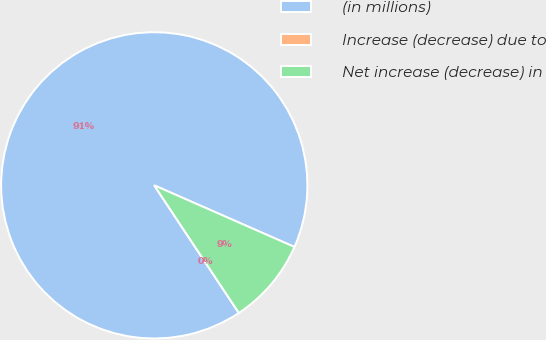Convert chart. <chart><loc_0><loc_0><loc_500><loc_500><pie_chart><fcel>(in millions)<fcel>Increase (decrease) due to<fcel>Net increase (decrease) in<nl><fcel>90.91%<fcel>0.0%<fcel>9.09%<nl></chart> 